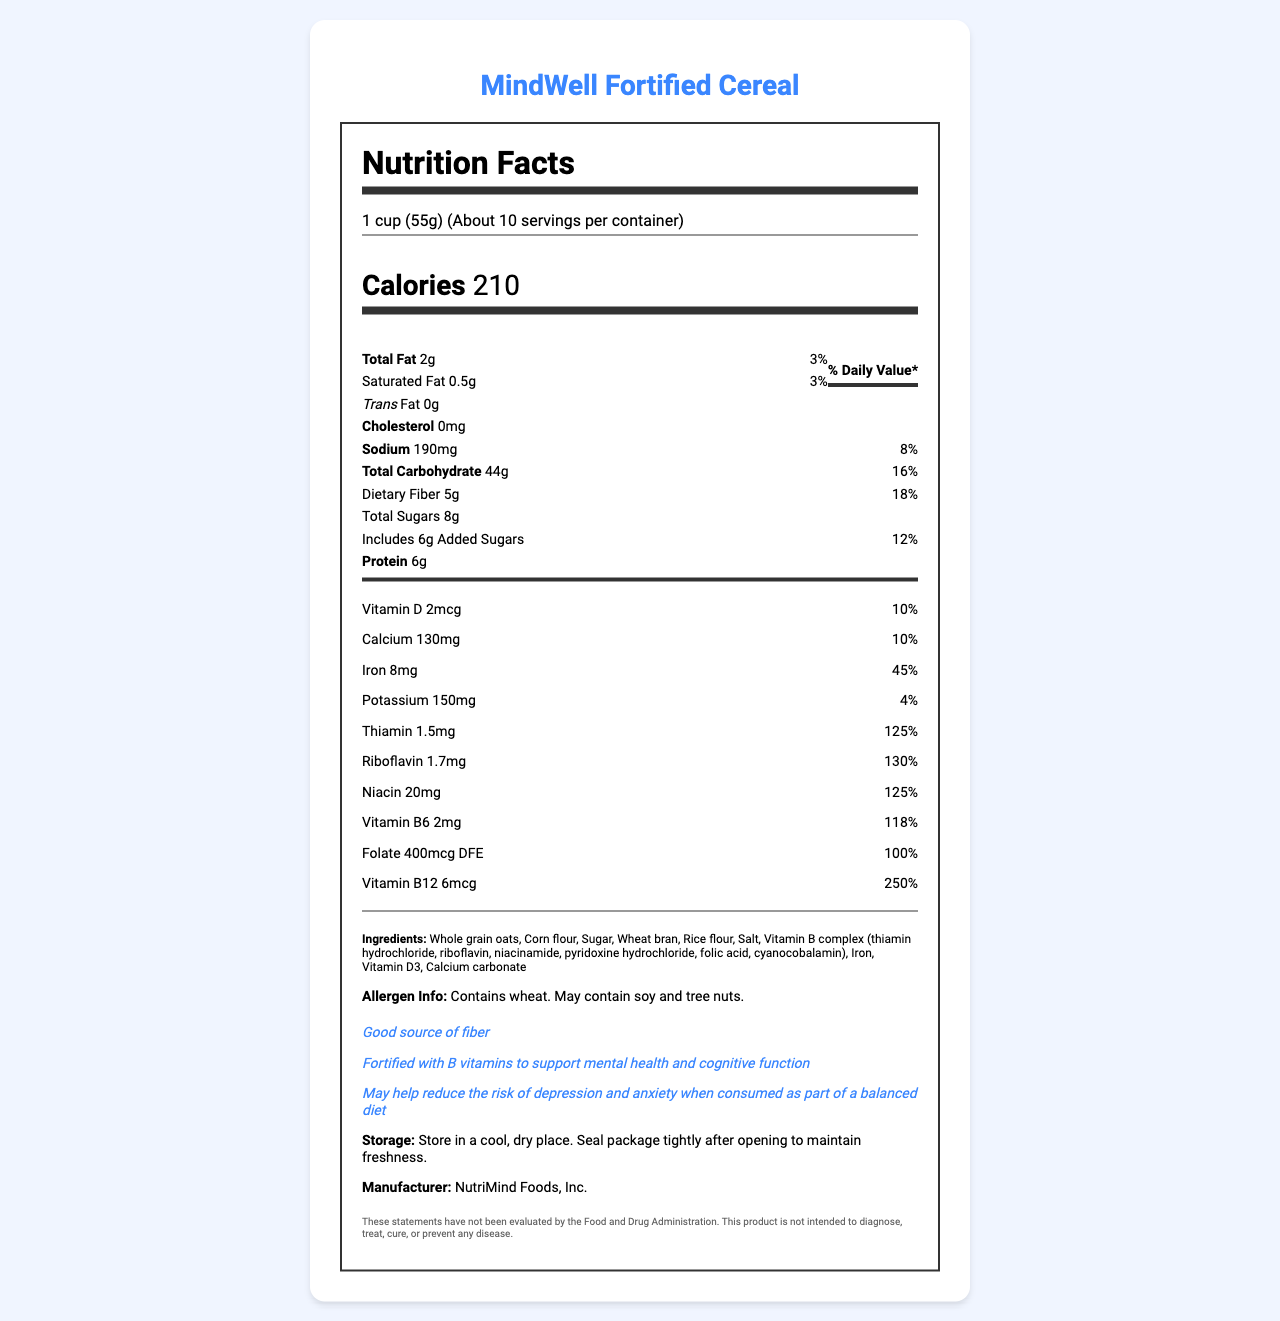What is the serving size of MindWell Fortified Cereal? The serving size is listed at the top of the nutrition label as "1 cup (55g)".
Answer: 1 cup (55g) How many calories are in one serving of MindWell Fortified Cereal? The number of calories per serving is listed prominently as "Calories 210".
Answer: 210 What is the percentage of the daily value for Iron in one serving of this cereal? The daily value percentage for Iron is noted as "Iron 8mg 45%" in the vitamin section of the label.
Answer: 45% Does this cereal contain any trans fat? The label specifies "Trans Fat 0g".
Answer: No What are two key vitamins in the Vitamin B complex included in this cereal? Both Thiamin and Riboflavin are listed under the Vitamin B complex section with their amounts and daily values.
Answer: Thiamin and Riboflavin How much dietary fiber does one serving of this cereal provide? The dietary fiber amount is listed as "Dietary Fiber 5g".
Answer: 5g List three ingredients found in MindWell Fortified Cereal. The ingredients are listed towards the bottom of the label just before the allergen information section.
Answer: Whole grain oats, Corn flour, Sugar Which of the following is a health claim made by the manufacturer of this cereal? A. Supports heart health B. Contains probiotics C. Fortified with B vitamins to support mental health and cognitive function D. Helps with weight loss The health claims section clearly states "Fortified with B vitamins to support mental health and cognitive function".
Answer: C What is the daily value percentage for Vitamin B12 in this cereal? A. 125% B. 130% C. 118% D. 250% The daily value percentage for Vitamin B12 is listed as "Vitamin B12 6mcg 250%".
Answer: D Is there any cholesterol in this cereal? The label clearly states "Cholesterol 0mg".
Answer: No Summarize the main idea of the document. The document follows a typical format of a nutrition facts label, detailing content per serving, percentages of daily values, and additional claims regarding mental health benefits due to B vitamin fortification.
Answer: The document provides the nutritional information for MindWell Fortified Cereal, highlighting its serving size, calories, macronutrient content, vitamin and mineral composition, ingredients, and health claims. A notable feature is the high content of B vitamins aimed at supporting mental health and cognitive function. How much sodium does one serving of this cereal contain? The sodium content is listed as "Sodium 190mg" with a daily value percentage of 8%.
Answer: 190mg Does this cereal contain any added sugars? If so, how much? The label specifies "Includes 6g Added Sugars" beneath the "Total Sugars" section.
Answer: Yes, 6g What is the disclaimer provided at the end of this document? The disclaimer appears at the bottom of the document after the manufacturer information.
Answer: These statements have not been evaluated by the Food and Drug Administration. This product is not intended to diagnose, treat, cure, or prevent any disease. Based on the document, how should you store MindWell Fortified Cereal? The storage instructions are clearly provided just before the manufacturer information.
Answer: Store in a cool, dry place. Seal package tightly after opening to maintain freshness. Can the allergens soy and tree nuts be definitively confirmed to be in the cereal? The allergen information states "May contain soy and tree nuts," indicating potential, but not confirmed, presence.
Answer: No 